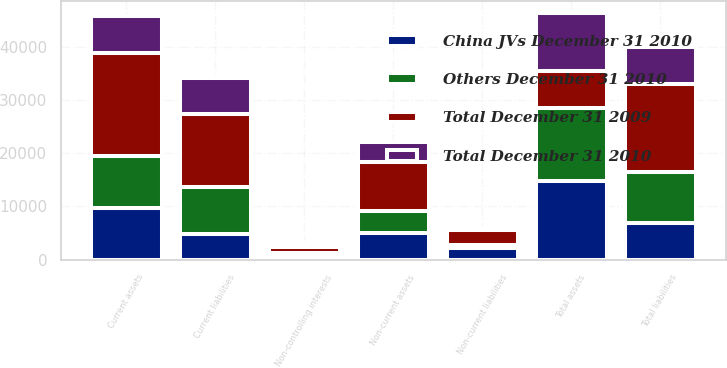Convert chart to OTSL. <chart><loc_0><loc_0><loc_500><loc_500><stacked_bar_chart><ecel><fcel>Current assets<fcel>Non-current assets<fcel>Total assets<fcel>Current liabilities<fcel>Non-current liabilities<fcel>Total liabilities<fcel>Non-controlling interests<nl><fcel>Others December 31 2010<fcel>9689<fcel>4147<fcel>13836<fcel>8931<fcel>580<fcel>9511<fcel>766<nl><fcel>China JVs December 31 2010<fcel>9708<fcel>5001<fcel>14709<fcel>4745<fcel>2232<fcel>6977<fcel>474<nl><fcel>Total December 31 2009<fcel>19397<fcel>9148<fcel>6954<fcel>13676<fcel>2812<fcel>16488<fcel>1240<nl><fcel>Total December 31 2010<fcel>6954<fcel>3794<fcel>10748<fcel>6695<fcel>302<fcel>6997<fcel>638<nl></chart> 